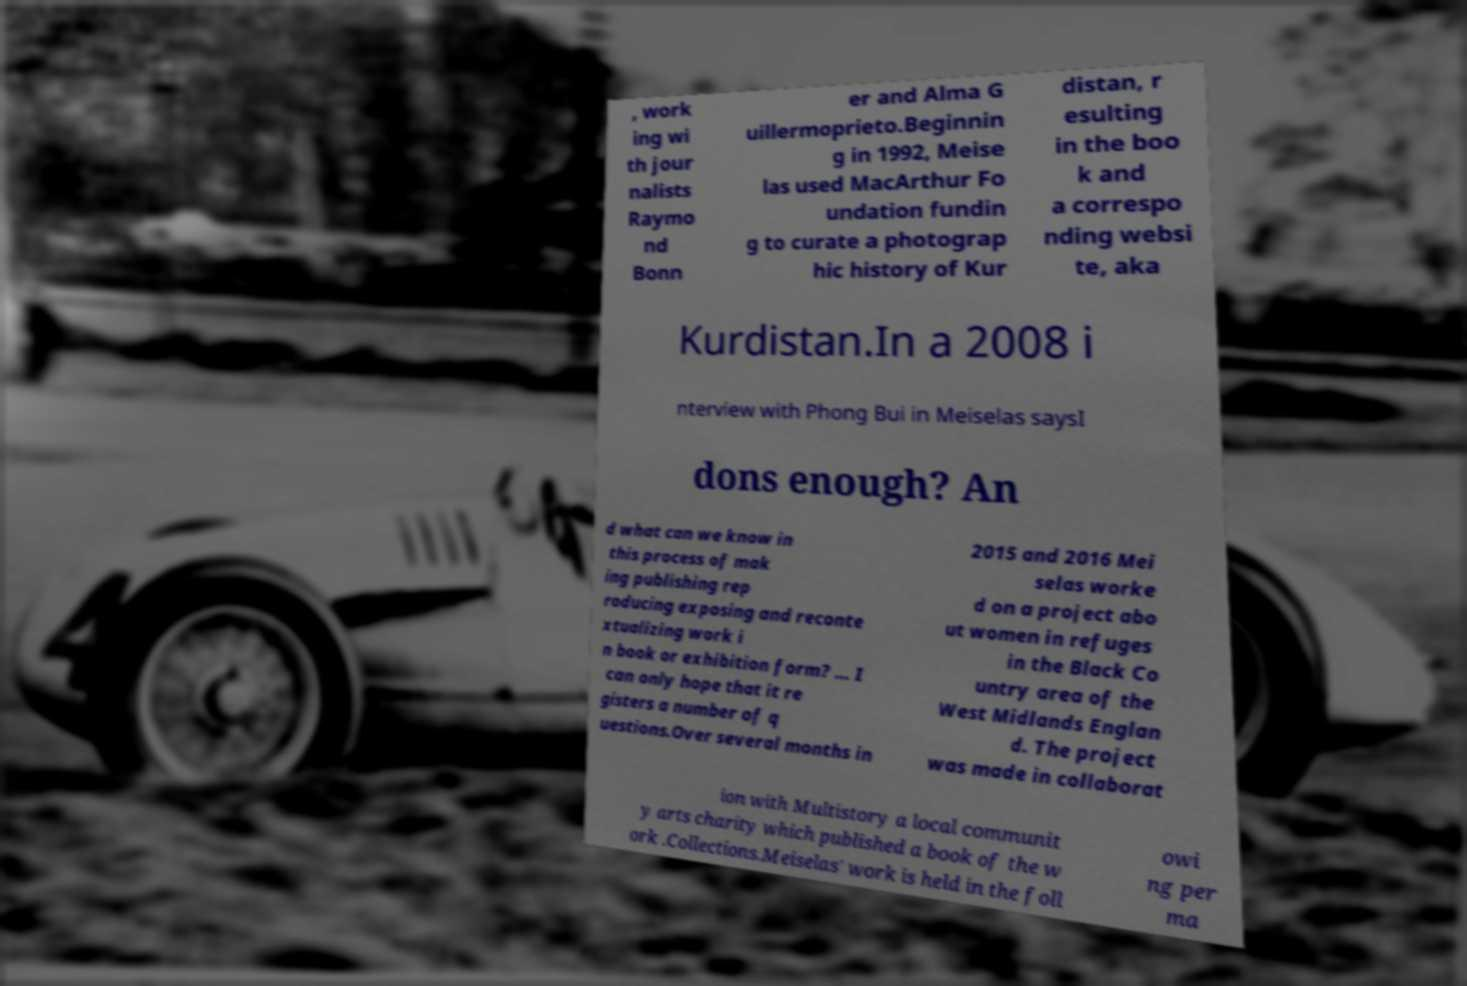What messages or text are displayed in this image? I need them in a readable, typed format. , work ing wi th jour nalists Raymo nd Bonn er and Alma G uillermoprieto.Beginnin g in 1992, Meise las used MacArthur Fo undation fundin g to curate a photograp hic history of Kur distan, r esulting in the boo k and a correspo nding websi te, aka Kurdistan.In a 2008 i nterview with Phong Bui in Meiselas saysI dons enough? An d what can we know in this process of mak ing publishing rep roducing exposing and reconte xtualizing work i n book or exhibition form? … I can only hope that it re gisters a number of q uestions.Over several months in 2015 and 2016 Mei selas worke d on a project abo ut women in refuges in the Black Co untry area of the West Midlands Englan d. The project was made in collaborat ion with Multistory a local communit y arts charity which published a book of the w ork .Collections.Meiselas' work is held in the foll owi ng per ma 